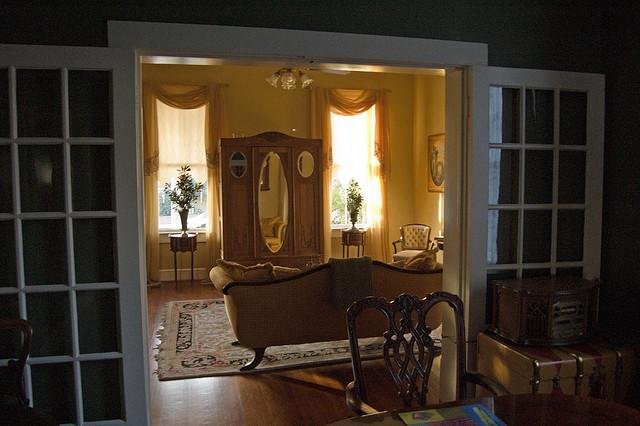What is at the far end of the room? flowers 